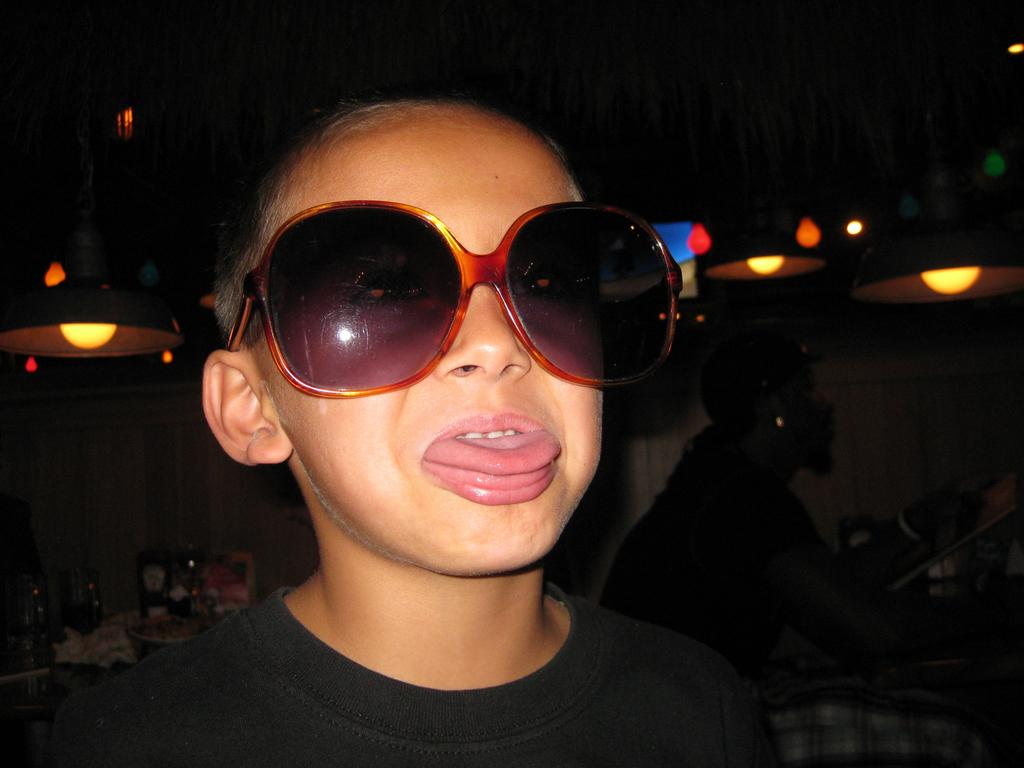What is the main subject of the image? The main subject of the image is a kid. What is the kid wearing in the image? The kid is wearing goggles in the image. Can you describe the background of the image? There are people in the background of the image. What type of lighting is present in the image? There are lights attached to the ceiling in the image. What is the rate of the car's speed in the image? There is no car present in the image, so it is not possible to determine the rate of its speed. 